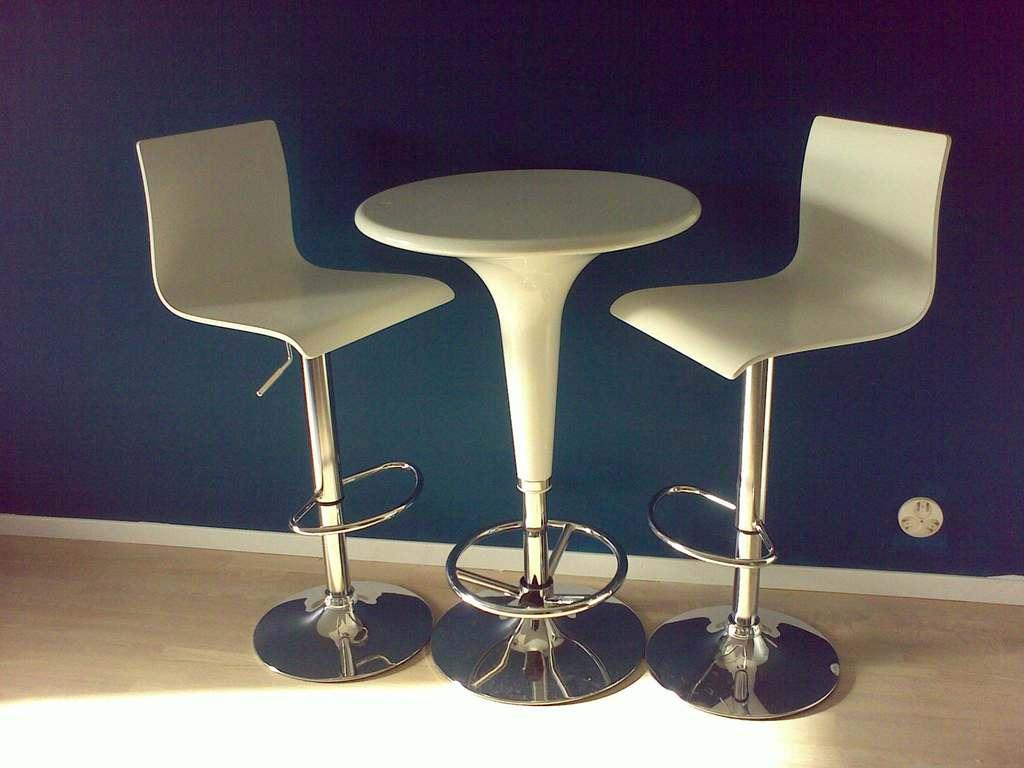What type of furniture is present in the image? There are chairs in the image. What other piece of furniture can be seen in the image? There is a table in the image. What is visible beneath the furniture? The ground is visible in the image. What is attached to the wall in the image? There is a wall with an object in the image. What type of feather can be seen on the table in the image? There is no feather present on the table in the image. 